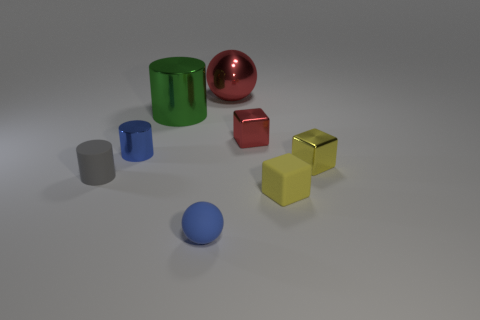What is the color of the ball that is behind the thing on the right side of the yellow thing in front of the tiny rubber cylinder?
Keep it short and to the point. Red. How many shiny things are either big red things or small blue cylinders?
Your response must be concise. 2. Are there more small blue objects that are behind the rubber cylinder than tiny blue shiny things that are right of the green metal object?
Your response must be concise. Yes. How many other things are there of the same size as the yellow metallic block?
Give a very brief answer. 5. How big is the cylinder behind the tiny metal thing on the left side of the big green metal cylinder?
Offer a terse response. Large. What number of big things are either blue cylinders or matte cubes?
Your answer should be compact. 0. How big is the red ball left of the tiny metallic cube in front of the tiny blue object behind the small sphere?
Provide a succinct answer. Large. Is there any other thing of the same color as the matte cylinder?
Provide a short and direct response. No. There is a small blue object that is right of the shiny cylinder that is behind the red metallic thing in front of the big red shiny sphere; what is its material?
Your answer should be very brief. Rubber. Is the tiny blue rubber object the same shape as the large red metallic object?
Offer a terse response. Yes. 